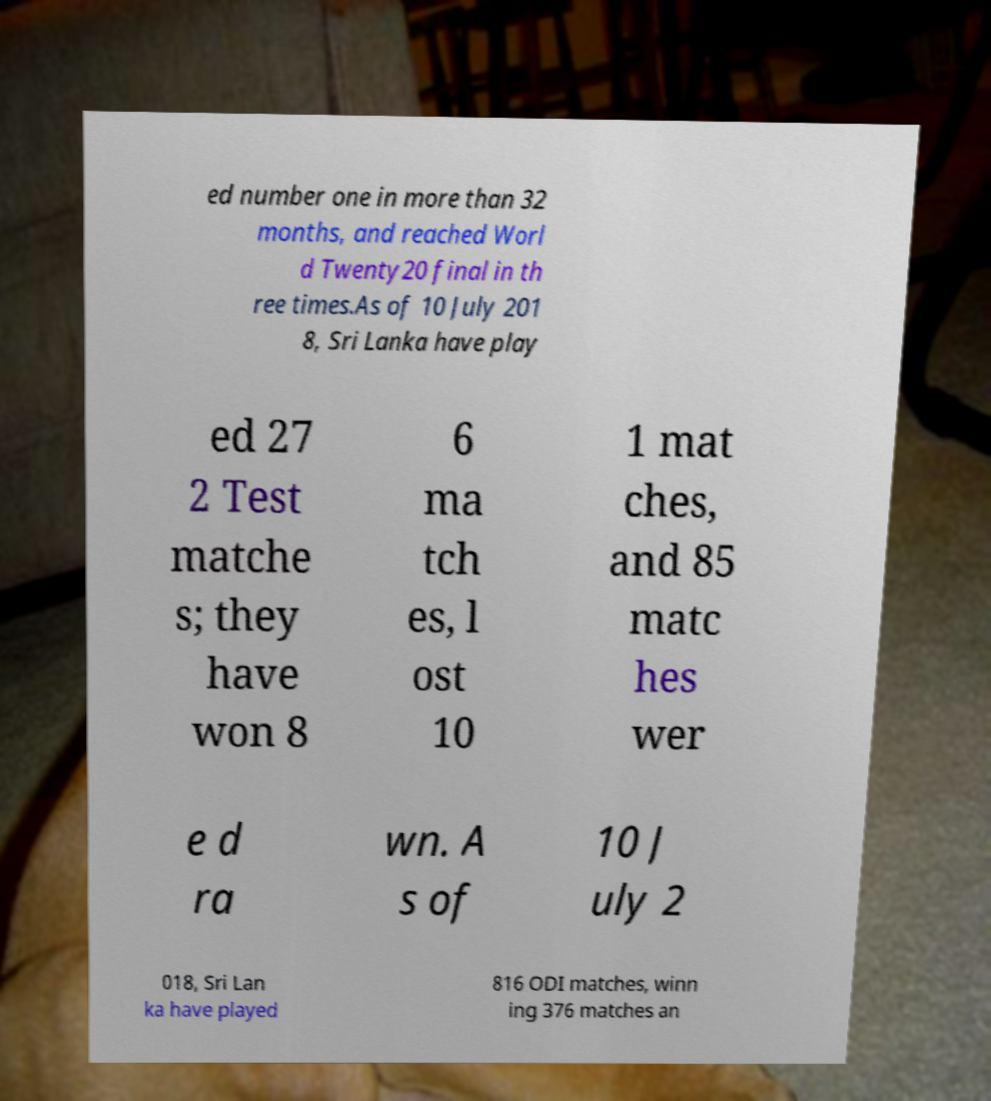What messages or text are displayed in this image? I need them in a readable, typed format. ed number one in more than 32 months, and reached Worl d Twenty20 final in th ree times.As of 10 July 201 8, Sri Lanka have play ed 27 2 Test matche s; they have won 8 6 ma tch es, l ost 10 1 mat ches, and 85 matc hes wer e d ra wn. A s of 10 J uly 2 018, Sri Lan ka have played 816 ODI matches, winn ing 376 matches an 